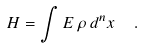Convert formula to latex. <formula><loc_0><loc_0><loc_500><loc_500>H = \int E \, \rho \, d ^ { n } x \ \ .</formula> 